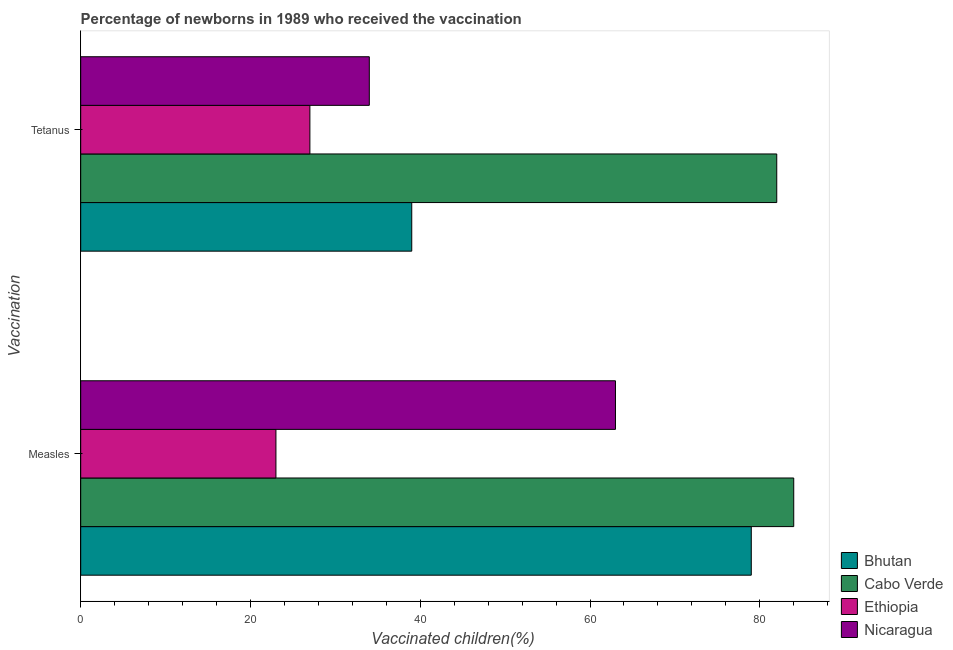How many different coloured bars are there?
Give a very brief answer. 4. Are the number of bars per tick equal to the number of legend labels?
Offer a terse response. Yes. Are the number of bars on each tick of the Y-axis equal?
Provide a short and direct response. Yes. How many bars are there on the 2nd tick from the top?
Give a very brief answer. 4. How many bars are there on the 2nd tick from the bottom?
Ensure brevity in your answer.  4. What is the label of the 2nd group of bars from the top?
Offer a very short reply. Measles. What is the percentage of newborns who received vaccination for tetanus in Nicaragua?
Offer a very short reply. 34. Across all countries, what is the maximum percentage of newborns who received vaccination for measles?
Your response must be concise. 84. Across all countries, what is the minimum percentage of newborns who received vaccination for tetanus?
Your answer should be very brief. 27. In which country was the percentage of newborns who received vaccination for measles maximum?
Make the answer very short. Cabo Verde. In which country was the percentage of newborns who received vaccination for tetanus minimum?
Your answer should be compact. Ethiopia. What is the total percentage of newborns who received vaccination for measles in the graph?
Offer a terse response. 249. What is the difference between the percentage of newborns who received vaccination for tetanus in Bhutan and that in Cabo Verde?
Your response must be concise. -43. What is the difference between the percentage of newborns who received vaccination for tetanus in Bhutan and the percentage of newborns who received vaccination for measles in Cabo Verde?
Your answer should be compact. -45. What is the average percentage of newborns who received vaccination for tetanus per country?
Your answer should be compact. 45.5. What is the difference between the percentage of newborns who received vaccination for tetanus and percentage of newborns who received vaccination for measles in Bhutan?
Provide a succinct answer. -40. In how many countries, is the percentage of newborns who received vaccination for measles greater than 16 %?
Your response must be concise. 4. What is the ratio of the percentage of newborns who received vaccination for tetanus in Nicaragua to that in Ethiopia?
Ensure brevity in your answer.  1.26. Is the percentage of newborns who received vaccination for tetanus in Cabo Verde less than that in Bhutan?
Your answer should be very brief. No. In how many countries, is the percentage of newborns who received vaccination for measles greater than the average percentage of newborns who received vaccination for measles taken over all countries?
Your answer should be compact. 3. What does the 4th bar from the top in Tetanus represents?
Keep it short and to the point. Bhutan. What does the 2nd bar from the bottom in Measles represents?
Give a very brief answer. Cabo Verde. How many bars are there?
Give a very brief answer. 8. Are all the bars in the graph horizontal?
Make the answer very short. Yes. How many countries are there in the graph?
Provide a short and direct response. 4. What is the difference between two consecutive major ticks on the X-axis?
Your answer should be very brief. 20. Are the values on the major ticks of X-axis written in scientific E-notation?
Give a very brief answer. No. Does the graph contain grids?
Provide a short and direct response. No. How many legend labels are there?
Your answer should be compact. 4. How are the legend labels stacked?
Your answer should be very brief. Vertical. What is the title of the graph?
Your answer should be compact. Percentage of newborns in 1989 who received the vaccination. Does "Korea (Democratic)" appear as one of the legend labels in the graph?
Provide a short and direct response. No. What is the label or title of the X-axis?
Offer a very short reply. Vaccinated children(%)
. What is the label or title of the Y-axis?
Give a very brief answer. Vaccination. What is the Vaccinated children(%)
 of Bhutan in Measles?
Provide a short and direct response. 79. What is the Vaccinated children(%)
 of Ethiopia in Measles?
Offer a very short reply. 23. What is the Vaccinated children(%)
 in Ethiopia in Tetanus?
Provide a short and direct response. 27. What is the Vaccinated children(%)
 in Nicaragua in Tetanus?
Give a very brief answer. 34. Across all Vaccination, what is the maximum Vaccinated children(%)
 of Bhutan?
Keep it short and to the point. 79. Across all Vaccination, what is the maximum Vaccinated children(%)
 in Cabo Verde?
Provide a succinct answer. 84. Across all Vaccination, what is the maximum Vaccinated children(%)
 in Nicaragua?
Your answer should be very brief. 63. Across all Vaccination, what is the minimum Vaccinated children(%)
 of Bhutan?
Your answer should be very brief. 39. Across all Vaccination, what is the minimum Vaccinated children(%)
 in Cabo Verde?
Your answer should be compact. 82. What is the total Vaccinated children(%)
 of Bhutan in the graph?
Your answer should be compact. 118. What is the total Vaccinated children(%)
 in Cabo Verde in the graph?
Offer a terse response. 166. What is the total Vaccinated children(%)
 in Nicaragua in the graph?
Your response must be concise. 97. What is the difference between the Vaccinated children(%)
 in Ethiopia in Measles and that in Tetanus?
Provide a succinct answer. -4. What is the difference between the Vaccinated children(%)
 of Nicaragua in Measles and that in Tetanus?
Offer a very short reply. 29. What is the difference between the Vaccinated children(%)
 in Bhutan in Measles and the Vaccinated children(%)
 in Ethiopia in Tetanus?
Keep it short and to the point. 52. What is the difference between the Vaccinated children(%)
 of Bhutan in Measles and the Vaccinated children(%)
 of Nicaragua in Tetanus?
Offer a very short reply. 45. What is the difference between the Vaccinated children(%)
 in Cabo Verde in Measles and the Vaccinated children(%)
 in Nicaragua in Tetanus?
Your answer should be very brief. 50. What is the difference between the Vaccinated children(%)
 of Ethiopia in Measles and the Vaccinated children(%)
 of Nicaragua in Tetanus?
Make the answer very short. -11. What is the average Vaccinated children(%)
 of Cabo Verde per Vaccination?
Your answer should be very brief. 83. What is the average Vaccinated children(%)
 of Ethiopia per Vaccination?
Make the answer very short. 25. What is the average Vaccinated children(%)
 in Nicaragua per Vaccination?
Your response must be concise. 48.5. What is the difference between the Vaccinated children(%)
 in Bhutan and Vaccinated children(%)
 in Cabo Verde in Measles?
Your answer should be very brief. -5. What is the difference between the Vaccinated children(%)
 in Bhutan and Vaccinated children(%)
 in Nicaragua in Measles?
Offer a very short reply. 16. What is the difference between the Vaccinated children(%)
 in Cabo Verde and Vaccinated children(%)
 in Ethiopia in Measles?
Provide a succinct answer. 61. What is the difference between the Vaccinated children(%)
 of Ethiopia and Vaccinated children(%)
 of Nicaragua in Measles?
Ensure brevity in your answer.  -40. What is the difference between the Vaccinated children(%)
 in Bhutan and Vaccinated children(%)
 in Cabo Verde in Tetanus?
Make the answer very short. -43. What is the difference between the Vaccinated children(%)
 of Cabo Verde and Vaccinated children(%)
 of Ethiopia in Tetanus?
Offer a terse response. 55. What is the difference between the Vaccinated children(%)
 of Cabo Verde and Vaccinated children(%)
 of Nicaragua in Tetanus?
Offer a terse response. 48. What is the difference between the Vaccinated children(%)
 of Ethiopia and Vaccinated children(%)
 of Nicaragua in Tetanus?
Provide a succinct answer. -7. What is the ratio of the Vaccinated children(%)
 in Bhutan in Measles to that in Tetanus?
Make the answer very short. 2.03. What is the ratio of the Vaccinated children(%)
 in Cabo Verde in Measles to that in Tetanus?
Give a very brief answer. 1.02. What is the ratio of the Vaccinated children(%)
 in Ethiopia in Measles to that in Tetanus?
Offer a very short reply. 0.85. What is the ratio of the Vaccinated children(%)
 in Nicaragua in Measles to that in Tetanus?
Your response must be concise. 1.85. What is the difference between the highest and the second highest Vaccinated children(%)
 of Bhutan?
Your answer should be compact. 40. What is the difference between the highest and the lowest Vaccinated children(%)
 in Cabo Verde?
Offer a terse response. 2. What is the difference between the highest and the lowest Vaccinated children(%)
 in Nicaragua?
Provide a succinct answer. 29. 